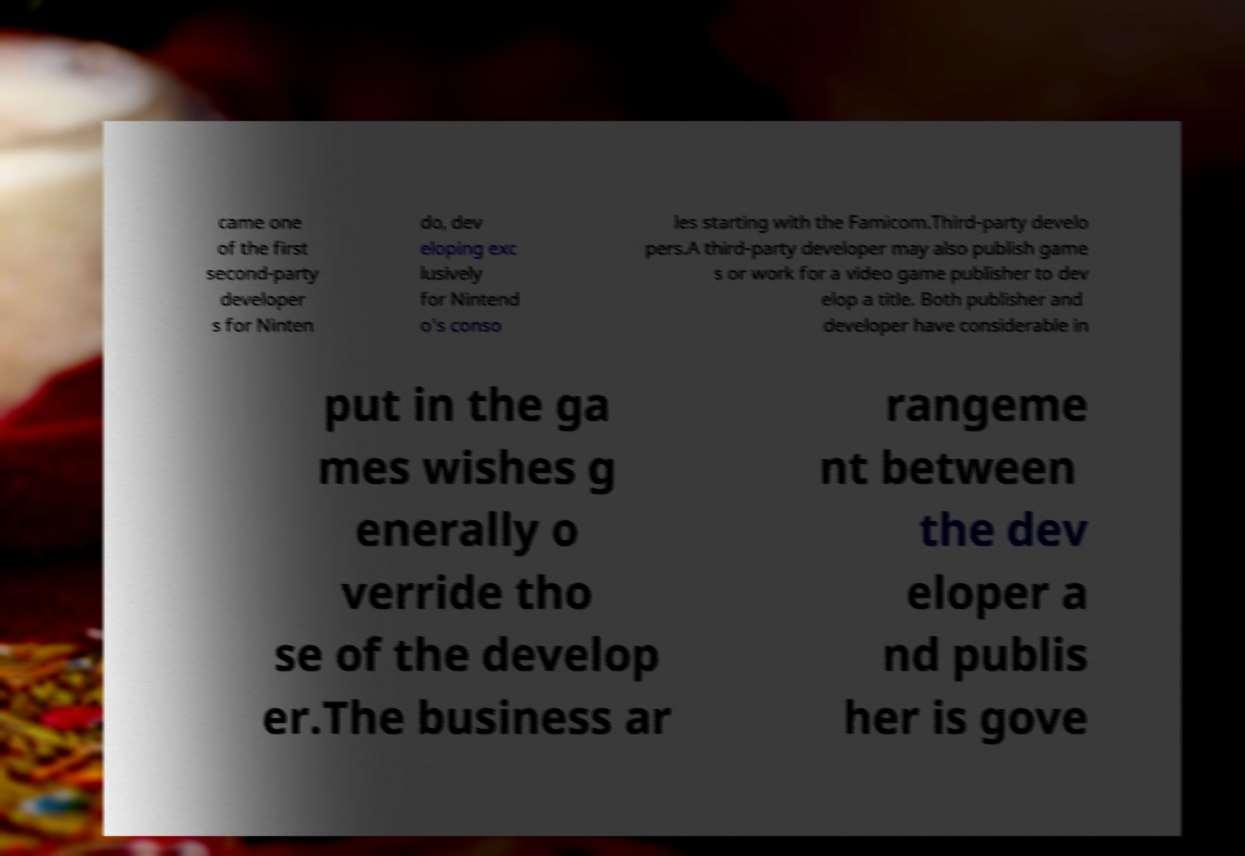Could you extract and type out the text from this image? came one of the first second-party developer s for Ninten do, dev eloping exc lusively for Nintend o's conso les starting with the Famicom.Third-party develo pers.A third-party developer may also publish game s or work for a video game publisher to dev elop a title. Both publisher and developer have considerable in put in the ga mes wishes g enerally o verride tho se of the develop er.The business ar rangeme nt between the dev eloper a nd publis her is gove 